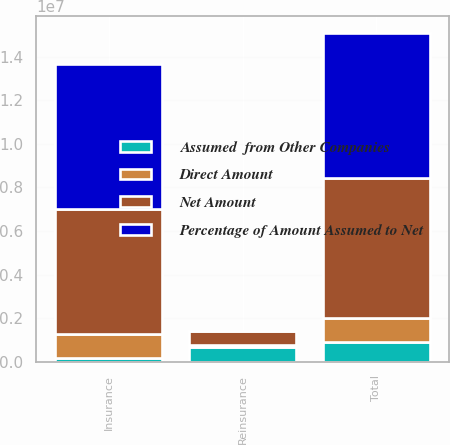Convert chart. <chart><loc_0><loc_0><loc_500><loc_500><stacked_bar_chart><ecel><fcel>Insurance<fcel>Reinsurance<fcel>Total<nl><fcel>Percentage of Amount Assumed to Net<fcel>6.63454e+06<fcel>13060<fcel>6.6476e+06<nl><fcel>Direct Amount<fcel>1.05915e+06<fcel>60639<fcel>1.11979e+06<nl><fcel>Assumed  from Other Companies<fcel>200522<fcel>695579<fcel>896101<nl><fcel>Net Amount<fcel>5.77591e+06<fcel>648000<fcel>6.42391e+06<nl></chart> 